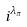Convert formula to latex. <formula><loc_0><loc_0><loc_500><loc_500>i ^ { \lambda _ { \pi } }</formula> 